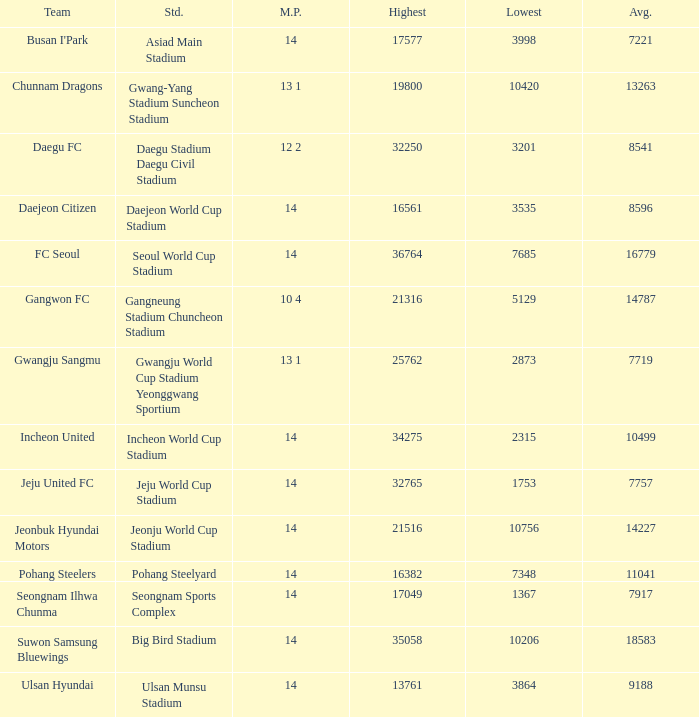What is the highest when pohang steelers is the team? 16382.0. 